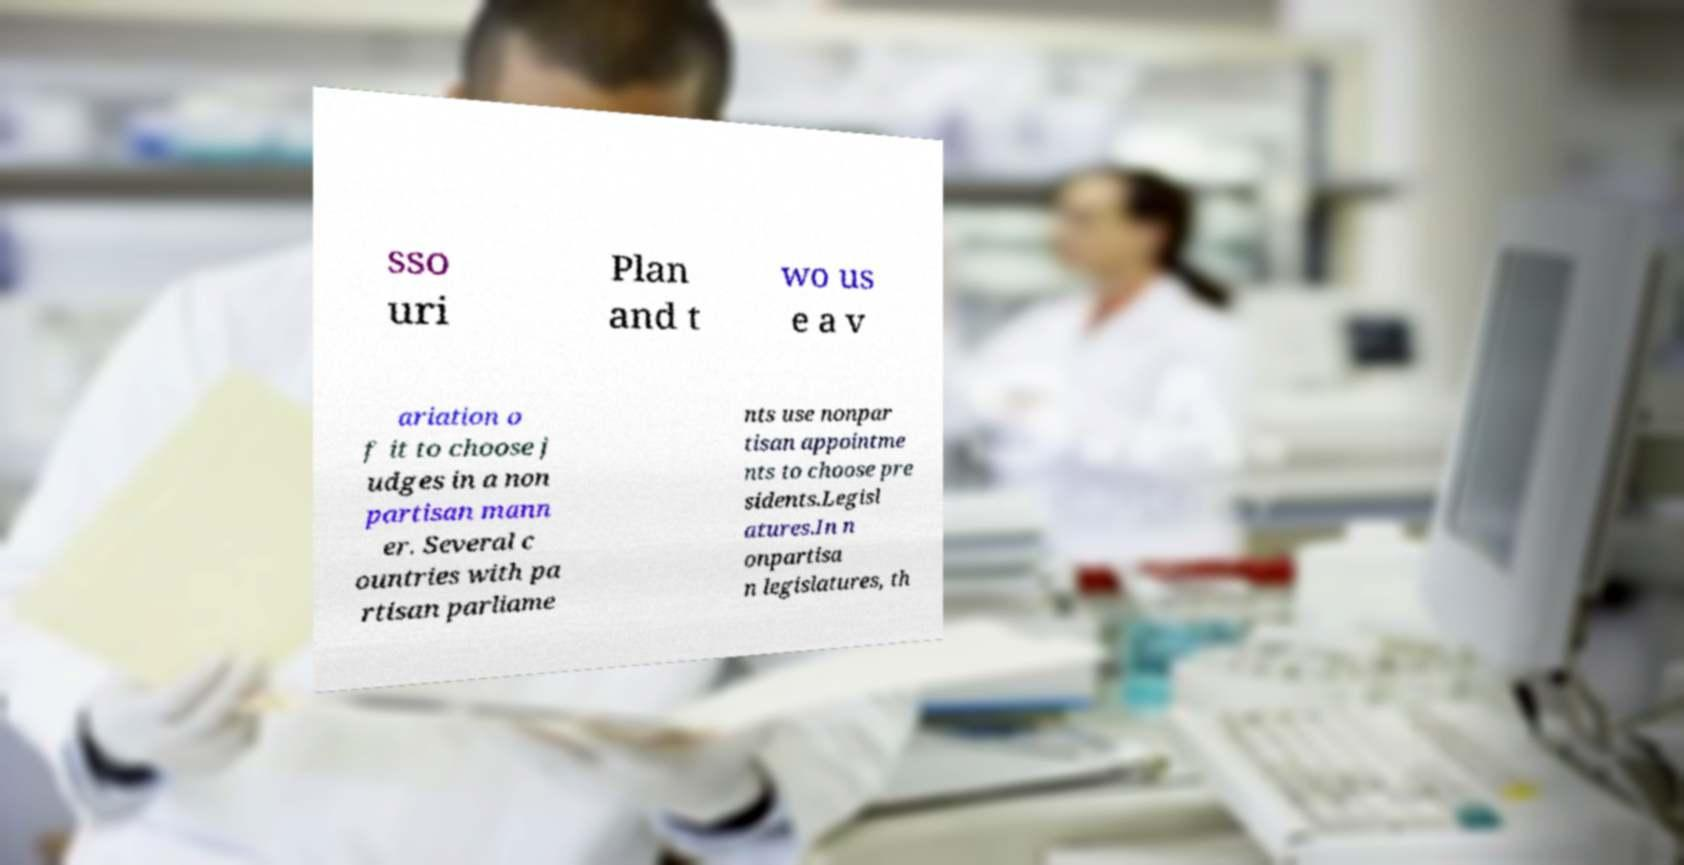Can you accurately transcribe the text from the provided image for me? sso uri Plan and t wo us e a v ariation o f it to choose j udges in a non partisan mann er. Several c ountries with pa rtisan parliame nts use nonpar tisan appointme nts to choose pre sidents.Legisl atures.In n onpartisa n legislatures, th 